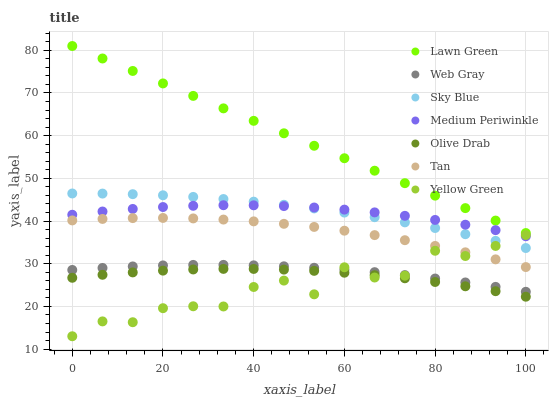Does Yellow Green have the minimum area under the curve?
Answer yes or no. Yes. Does Lawn Green have the maximum area under the curve?
Answer yes or no. Yes. Does Web Gray have the minimum area under the curve?
Answer yes or no. No. Does Web Gray have the maximum area under the curve?
Answer yes or no. No. Is Lawn Green the smoothest?
Answer yes or no. Yes. Is Yellow Green the roughest?
Answer yes or no. Yes. Is Web Gray the smoothest?
Answer yes or no. No. Is Web Gray the roughest?
Answer yes or no. No. Does Yellow Green have the lowest value?
Answer yes or no. Yes. Does Web Gray have the lowest value?
Answer yes or no. No. Does Lawn Green have the highest value?
Answer yes or no. Yes. Does Web Gray have the highest value?
Answer yes or no. No. Is Web Gray less than Sky Blue?
Answer yes or no. Yes. Is Sky Blue greater than Tan?
Answer yes or no. Yes. Does Yellow Green intersect Web Gray?
Answer yes or no. Yes. Is Yellow Green less than Web Gray?
Answer yes or no. No. Is Yellow Green greater than Web Gray?
Answer yes or no. No. Does Web Gray intersect Sky Blue?
Answer yes or no. No. 